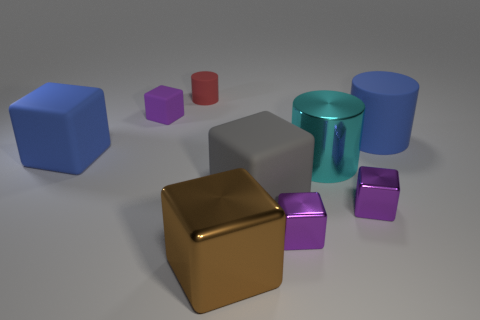There is a block that is in front of the large cyan object and to the left of the gray object; what size is it?
Provide a succinct answer. Large. There is a large brown shiny cube; are there any purple cubes behind it?
Give a very brief answer. Yes. Are there any purple rubber objects that are in front of the big blue thing right of the big brown metallic block?
Offer a very short reply. No. Are there the same number of small things that are in front of the big matte cylinder and metal objects on the right side of the brown cube?
Keep it short and to the point. No. There is a large cylinder that is made of the same material as the large brown block; what color is it?
Make the answer very short. Cyan. Is there a cylinder made of the same material as the cyan thing?
Give a very brief answer. No. How many things are either large brown objects or red cylinders?
Your answer should be very brief. 2. Do the cyan object and the big blue object on the left side of the small purple rubber object have the same material?
Ensure brevity in your answer.  No. There is a blue object to the right of the gray matte cube; how big is it?
Provide a short and direct response. Large. Is the number of tiny brown rubber balls less than the number of purple things?
Give a very brief answer. Yes. 